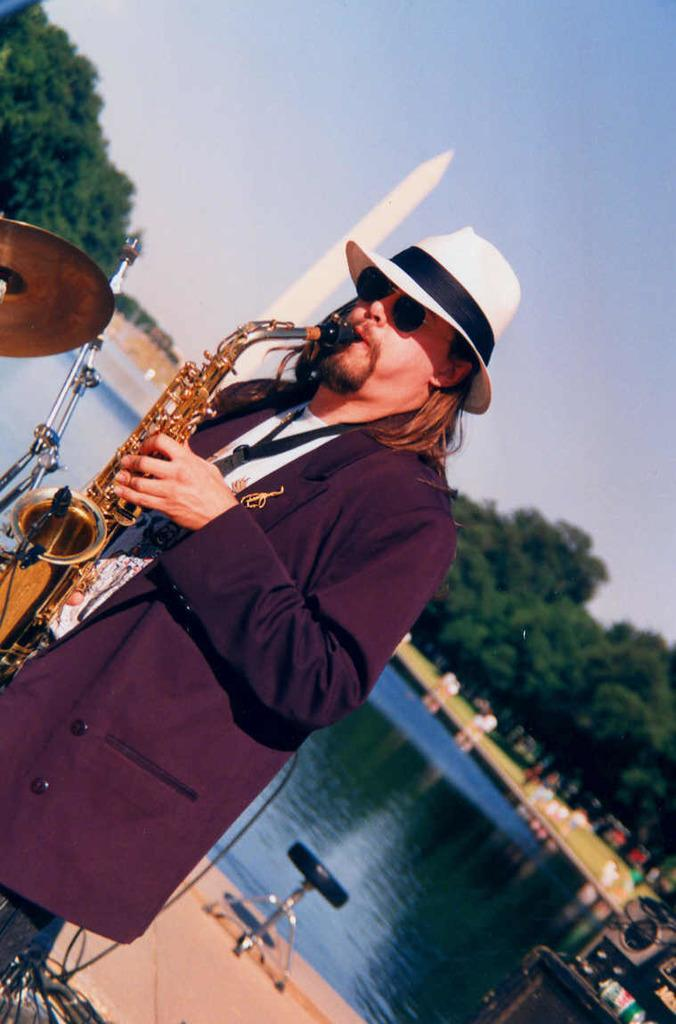What is the person in the image holding? The person in the image is holding a musical instrument. What type of natural environment can be seen in the image? Trees and water are visible in the image, indicating a natural environment. What part of the sky is visible in the image? The sky is visible in the image. What other objects can be seen in the image besides the person and the musical instrument? There are other objects present in the image. What type of marble is being used to play the musical instrument in the image? There is no marble present in the image, and the musical instrument is not being played with any type of marble. 